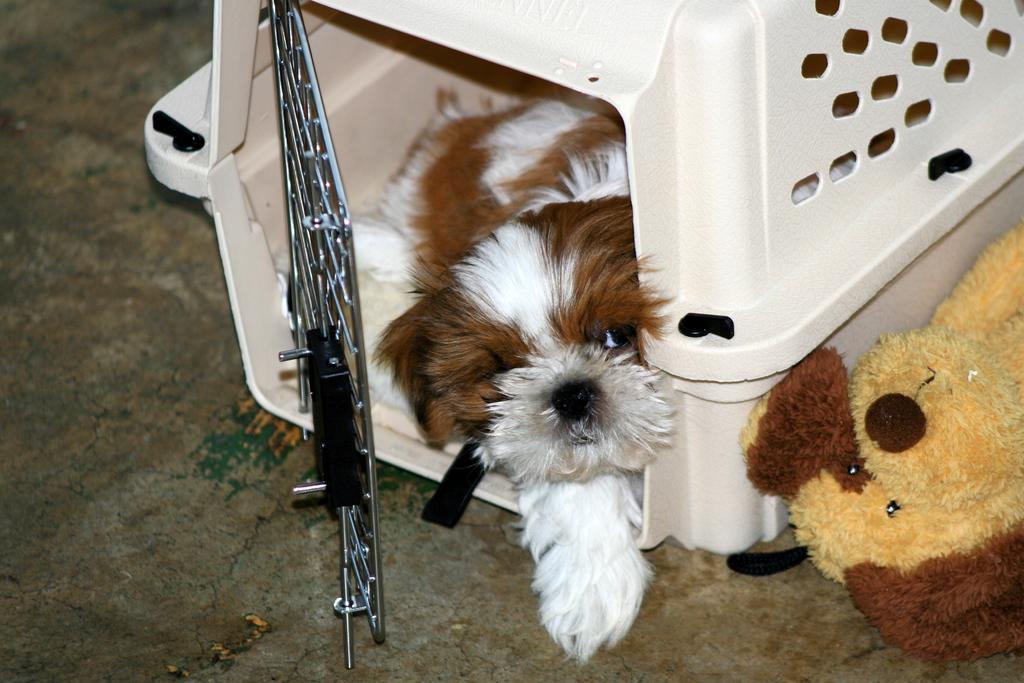Can you describe this image briefly? In this image I can see the dog in white and brown color and the dog is in the white color cage and I can also see the toy dog in brown and cream color 